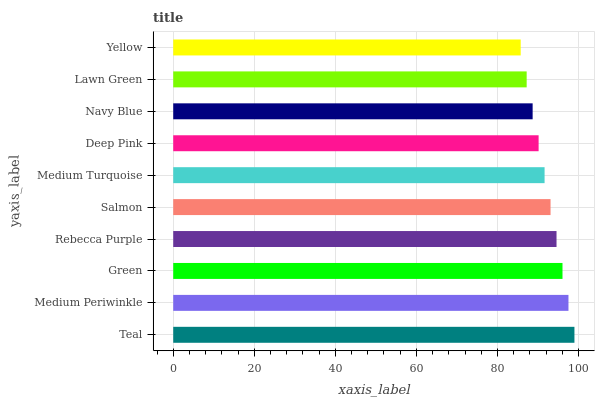Is Yellow the minimum?
Answer yes or no. Yes. Is Teal the maximum?
Answer yes or no. Yes. Is Medium Periwinkle the minimum?
Answer yes or no. No. Is Medium Periwinkle the maximum?
Answer yes or no. No. Is Teal greater than Medium Periwinkle?
Answer yes or no. Yes. Is Medium Periwinkle less than Teal?
Answer yes or no. Yes. Is Medium Periwinkle greater than Teal?
Answer yes or no. No. Is Teal less than Medium Periwinkle?
Answer yes or no. No. Is Salmon the high median?
Answer yes or no. Yes. Is Medium Turquoise the low median?
Answer yes or no. Yes. Is Medium Periwinkle the high median?
Answer yes or no. No. Is Medium Periwinkle the low median?
Answer yes or no. No. 